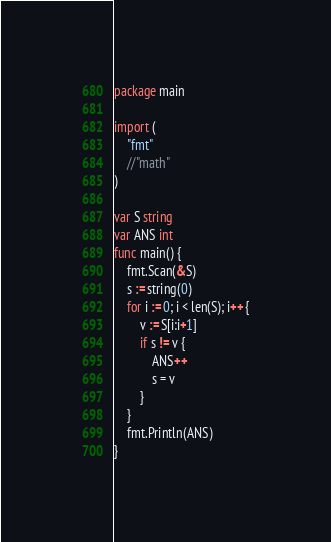Convert code to text. <code><loc_0><loc_0><loc_500><loc_500><_Go_>package main
 
import (
	"fmt"
	//"math"
)
 
var S string
var ANS int
func main() {
	fmt.Scan(&S)
	s := string(0) 
	for i := 0; i < len(S); i++ {
		v := S[i:i+1]
		if s != v {
			ANS++
			s = v
		}
	}
	fmt.Println(ANS)
}
</code> 